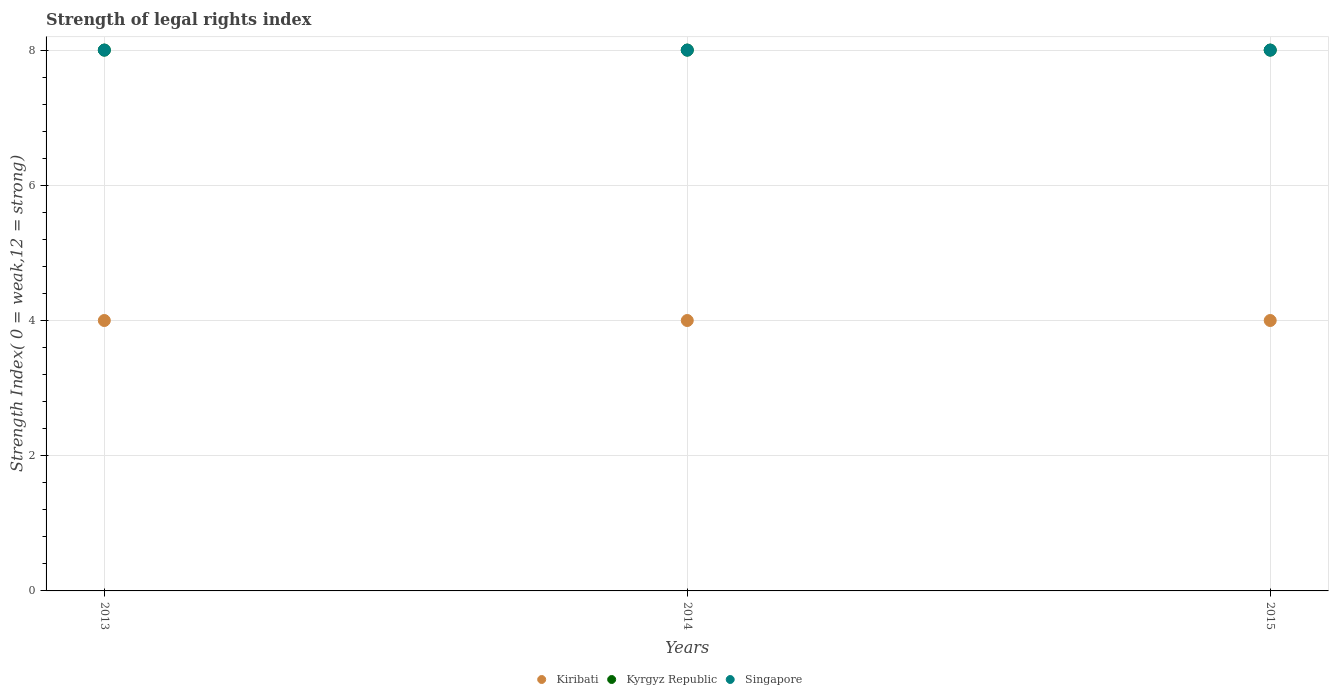Is the number of dotlines equal to the number of legend labels?
Provide a succinct answer. Yes. What is the strength index in Kiribati in 2015?
Your answer should be compact. 4. Across all years, what is the maximum strength index in Kyrgyz Republic?
Offer a terse response. 8. Across all years, what is the minimum strength index in Singapore?
Your response must be concise. 8. In which year was the strength index in Kyrgyz Republic maximum?
Ensure brevity in your answer.  2013. What is the total strength index in Kyrgyz Republic in the graph?
Provide a succinct answer. 24. What is the difference between the strength index in Kyrgyz Republic in 2013 and the strength index in Kiribati in 2014?
Provide a succinct answer. 4. What is the average strength index in Kiribati per year?
Provide a short and direct response. 4. In the year 2013, what is the difference between the strength index in Kiribati and strength index in Kyrgyz Republic?
Provide a short and direct response. -4. Is the strength index in Singapore in 2013 less than that in 2015?
Offer a terse response. No. What is the difference between the highest and the second highest strength index in Kyrgyz Republic?
Give a very brief answer. 0. What is the difference between the highest and the lowest strength index in Kiribati?
Make the answer very short. 0. Is the sum of the strength index in Kyrgyz Republic in 2014 and 2015 greater than the maximum strength index in Kiribati across all years?
Your answer should be very brief. Yes. Is it the case that in every year, the sum of the strength index in Kyrgyz Republic and strength index in Kiribati  is greater than the strength index in Singapore?
Offer a very short reply. Yes. How many years are there in the graph?
Your response must be concise. 3. What is the difference between two consecutive major ticks on the Y-axis?
Offer a very short reply. 2. Does the graph contain any zero values?
Your response must be concise. No. Where does the legend appear in the graph?
Give a very brief answer. Bottom center. How many legend labels are there?
Offer a terse response. 3. What is the title of the graph?
Provide a short and direct response. Strength of legal rights index. Does "Algeria" appear as one of the legend labels in the graph?
Keep it short and to the point. No. What is the label or title of the X-axis?
Keep it short and to the point. Years. What is the label or title of the Y-axis?
Ensure brevity in your answer.  Strength Index( 0 = weak,12 = strong). What is the Strength Index( 0 = weak,12 = strong) of Kiribati in 2013?
Your answer should be very brief. 4. What is the Strength Index( 0 = weak,12 = strong) of Kyrgyz Republic in 2013?
Offer a very short reply. 8. What is the Strength Index( 0 = weak,12 = strong) in Singapore in 2013?
Give a very brief answer. 8. What is the Strength Index( 0 = weak,12 = strong) in Kiribati in 2014?
Your answer should be compact. 4. What is the Strength Index( 0 = weak,12 = strong) in Kiribati in 2015?
Ensure brevity in your answer.  4. What is the Strength Index( 0 = weak,12 = strong) in Kyrgyz Republic in 2015?
Your answer should be very brief. 8. What is the Strength Index( 0 = weak,12 = strong) in Singapore in 2015?
Provide a short and direct response. 8. Across all years, what is the maximum Strength Index( 0 = weak,12 = strong) of Kiribati?
Provide a short and direct response. 4. Across all years, what is the maximum Strength Index( 0 = weak,12 = strong) of Kyrgyz Republic?
Provide a succinct answer. 8. Across all years, what is the maximum Strength Index( 0 = weak,12 = strong) in Singapore?
Your answer should be compact. 8. What is the total Strength Index( 0 = weak,12 = strong) of Kyrgyz Republic in the graph?
Ensure brevity in your answer.  24. What is the total Strength Index( 0 = weak,12 = strong) of Singapore in the graph?
Give a very brief answer. 24. What is the difference between the Strength Index( 0 = weak,12 = strong) in Kiribati in 2013 and that in 2014?
Provide a short and direct response. 0. What is the difference between the Strength Index( 0 = weak,12 = strong) of Kyrgyz Republic in 2013 and that in 2015?
Offer a very short reply. 0. What is the difference between the Strength Index( 0 = weak,12 = strong) in Singapore in 2013 and that in 2015?
Your response must be concise. 0. What is the difference between the Strength Index( 0 = weak,12 = strong) of Kiribati in 2014 and that in 2015?
Give a very brief answer. 0. What is the difference between the Strength Index( 0 = weak,12 = strong) of Kyrgyz Republic in 2014 and that in 2015?
Keep it short and to the point. 0. What is the difference between the Strength Index( 0 = weak,12 = strong) in Singapore in 2014 and that in 2015?
Offer a very short reply. 0. What is the difference between the Strength Index( 0 = weak,12 = strong) of Kiribati in 2013 and the Strength Index( 0 = weak,12 = strong) of Singapore in 2014?
Offer a very short reply. -4. What is the difference between the Strength Index( 0 = weak,12 = strong) in Kiribati in 2013 and the Strength Index( 0 = weak,12 = strong) in Singapore in 2015?
Your answer should be compact. -4. What is the difference between the Strength Index( 0 = weak,12 = strong) of Kiribati in 2014 and the Strength Index( 0 = weak,12 = strong) of Kyrgyz Republic in 2015?
Give a very brief answer. -4. What is the difference between the Strength Index( 0 = weak,12 = strong) in Kiribati in 2014 and the Strength Index( 0 = weak,12 = strong) in Singapore in 2015?
Your response must be concise. -4. What is the average Strength Index( 0 = weak,12 = strong) in Kyrgyz Republic per year?
Offer a very short reply. 8. What is the average Strength Index( 0 = weak,12 = strong) in Singapore per year?
Offer a very short reply. 8. In the year 2013, what is the difference between the Strength Index( 0 = weak,12 = strong) in Kiribati and Strength Index( 0 = weak,12 = strong) in Kyrgyz Republic?
Provide a short and direct response. -4. In the year 2013, what is the difference between the Strength Index( 0 = weak,12 = strong) of Kiribati and Strength Index( 0 = weak,12 = strong) of Singapore?
Your response must be concise. -4. In the year 2013, what is the difference between the Strength Index( 0 = weak,12 = strong) in Kyrgyz Republic and Strength Index( 0 = weak,12 = strong) in Singapore?
Offer a very short reply. 0. In the year 2014, what is the difference between the Strength Index( 0 = weak,12 = strong) in Kiribati and Strength Index( 0 = weak,12 = strong) in Kyrgyz Republic?
Ensure brevity in your answer.  -4. In the year 2015, what is the difference between the Strength Index( 0 = weak,12 = strong) in Kyrgyz Republic and Strength Index( 0 = weak,12 = strong) in Singapore?
Provide a succinct answer. 0. What is the ratio of the Strength Index( 0 = weak,12 = strong) in Kiribati in 2013 to that in 2014?
Provide a succinct answer. 1. What is the ratio of the Strength Index( 0 = weak,12 = strong) of Kyrgyz Republic in 2013 to that in 2014?
Ensure brevity in your answer.  1. What is the ratio of the Strength Index( 0 = weak,12 = strong) of Singapore in 2013 to that in 2014?
Provide a succinct answer. 1. What is the ratio of the Strength Index( 0 = weak,12 = strong) of Kiribati in 2013 to that in 2015?
Your response must be concise. 1. What is the ratio of the Strength Index( 0 = weak,12 = strong) in Kyrgyz Republic in 2013 to that in 2015?
Your answer should be very brief. 1. What is the ratio of the Strength Index( 0 = weak,12 = strong) in Singapore in 2013 to that in 2015?
Offer a terse response. 1. What is the ratio of the Strength Index( 0 = weak,12 = strong) in Singapore in 2014 to that in 2015?
Offer a terse response. 1. What is the difference between the highest and the second highest Strength Index( 0 = weak,12 = strong) in Kiribati?
Give a very brief answer. 0. What is the difference between the highest and the lowest Strength Index( 0 = weak,12 = strong) in Kyrgyz Republic?
Your response must be concise. 0. 